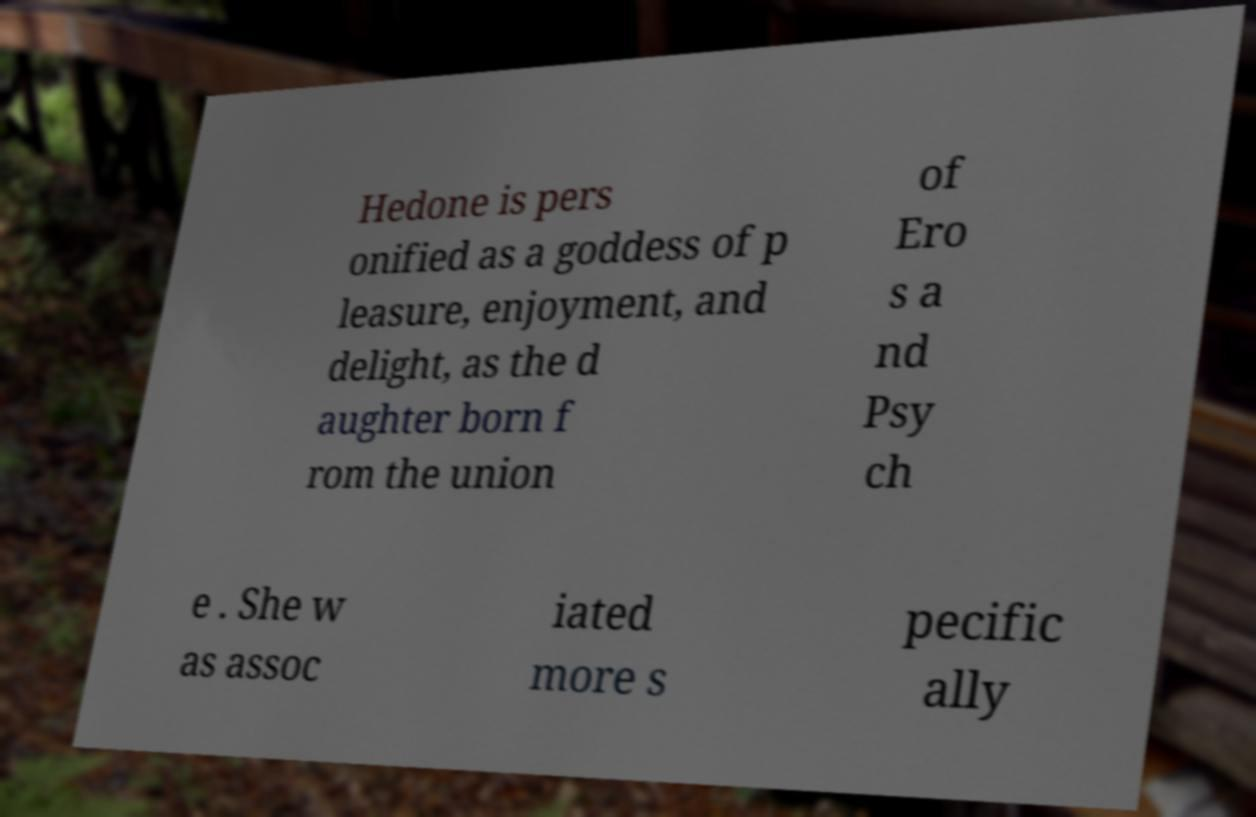Please read and relay the text visible in this image. What does it say? Hedone is pers onified as a goddess of p leasure, enjoyment, and delight, as the d aughter born f rom the union of Ero s a nd Psy ch e . She w as assoc iated more s pecific ally 